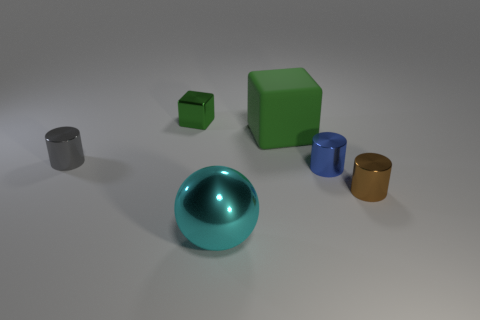There is a tiny blue thing; how many green rubber things are behind it?
Ensure brevity in your answer.  1. The thing that is to the left of the blue thing and in front of the small blue thing has what shape?
Keep it short and to the point. Sphere. There is a object that is the same color as the matte cube; what is it made of?
Your answer should be very brief. Metal. How many cubes are either small brown rubber objects or gray things?
Make the answer very short. 0. There is a object that is the same color as the tiny metallic block; what size is it?
Give a very brief answer. Large. Is the number of tiny brown shiny objects left of the green matte block less than the number of large cyan spheres?
Your response must be concise. Yes. What is the color of the object that is in front of the small blue metallic thing and to the left of the tiny brown metal thing?
Your answer should be compact. Cyan. What number of other objects are the same shape as the green rubber object?
Provide a succinct answer. 1. Are there fewer tiny blue things left of the tiny green metal block than small blue things to the right of the brown metallic object?
Make the answer very short. No. Is the material of the big block the same as the cylinder that is on the left side of the matte cube?
Make the answer very short. No. 